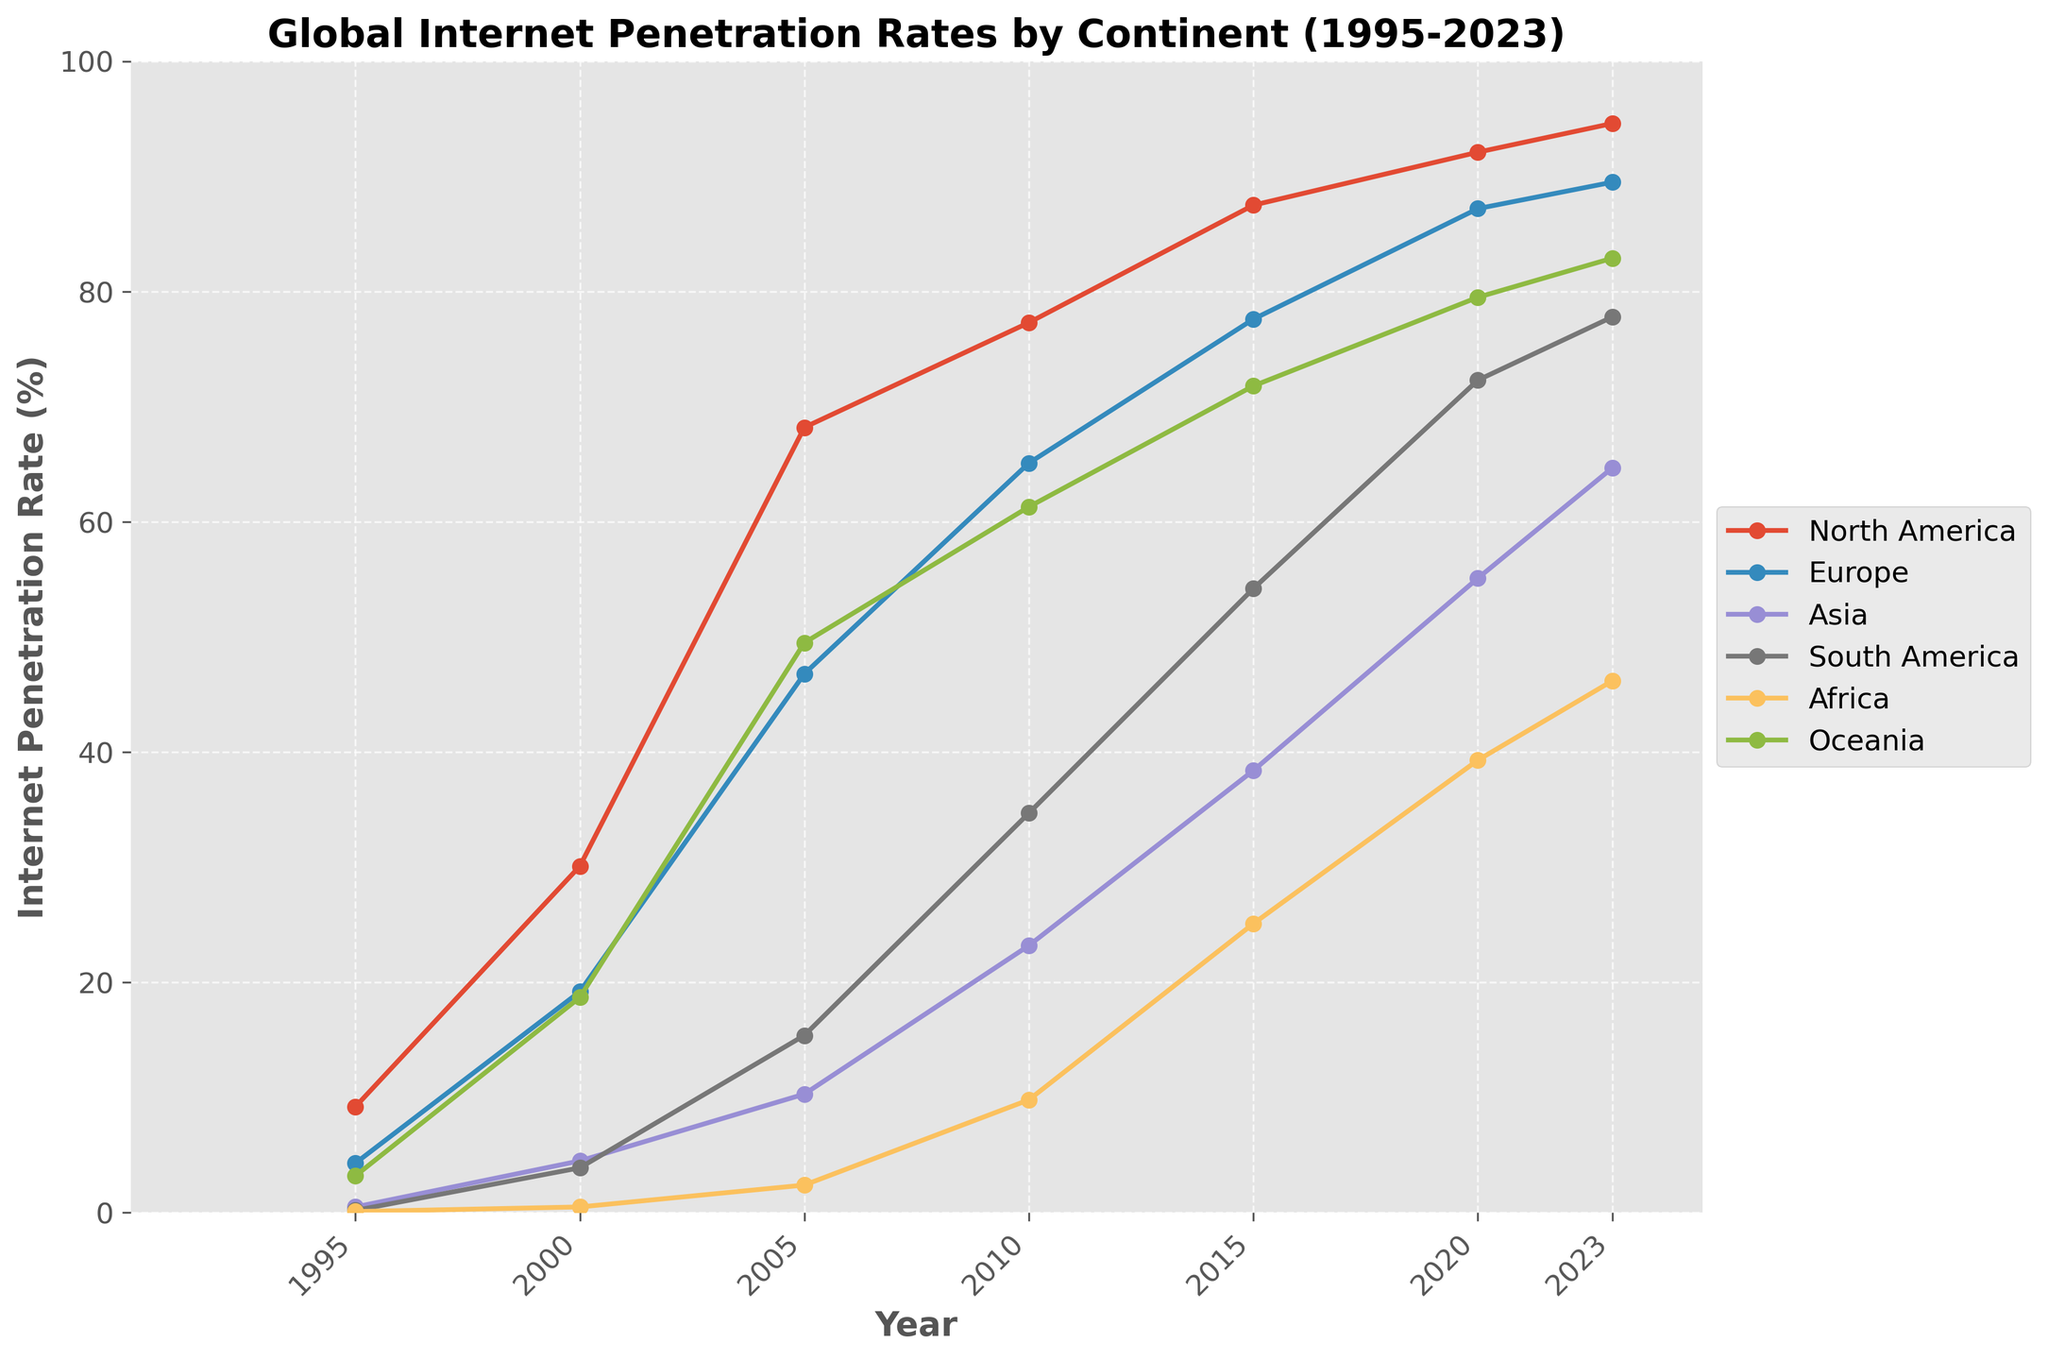What's the trend in internet penetration rates in Africa from 1995 to 2023? Looking at the line for Africa, we see that it starts very low in 1995 and shows a steady rise up until 2023. This indicates a consistent upward trend in internet penetration rates in Africa.
Answer: Steady upward trend Which continent had the highest internet penetration rate in 2005? Referring to the 2005 data points, the highest line on the chart corresponds to North America with an internet penetration rate of 68.2%.
Answer: North America How does the internet penetration rate in Oceania in 2023 compare to North America in 2000? In 2023, the penetration rate in Oceania is marked around 82.9%. In North America in 2000, it was 30.1%. Comparing these visually, Oceania in 2023 is much higher than North America in 2000.
Answer: Oceania in 2023 is higher What is the average internet penetration rate across all continents in 2010? To find the average for 2010, add all the rates for continents: 77.3 (North America) + 65.1 (Europe) + 23.2 (Asia) + 34.7 (South America) + 9.8 (Africa) + 61.3 (Oceania) = 271.4. Then, divide by the number of continents (6): 271.4 / 6 ≈ 45.23%.
Answer: ≈ 45.23% Between which years did Asia see the most significant increase in internet penetration rates? Examination of the line for Asia shows the most significant change between 2015 and 2020, moving from 38.4% to 55.1%. This is the largest leap compared to other periods.
Answer: 2015 to 2020 Which continent saw the least growth in internet penetration rate from 1995 to 2023? Comparing the vertical rise of each line from 1995 to 2023, Africa starts at 0.1% and ends at 46.2%, which indicates it has the least growth compared to the higher endpoints of other continents.
Answer: Africa What is the difference in internet penetration rates between Europe and South America in 2015? In 2015, Europe's rate is 77.6% and South America's is 54.2%. The difference is 77.6% - 54.2% = 23.4%.
Answer: 23.4% Which continent had the lowest internet penetration rate in 2000, and what was the rate? The lowest point on the 2000 axis corresponds to Africa with an internet penetration rate of 0.5%.
Answer: Africa, 0.5% How did South America's internet penetration rate change between 2010 and 2023? In 2010, it started at 34.7% and increased to 77.8% in 2023. This shows South America's rate more than doubled over the period.
Answer: More than doubled In 2020, which continents had internet penetration rates greater than 50%? Referring to the 2020 data points, North America, Europe, Asia, South America, and Oceania all have rates above 50%, while Africa does not.
Answer: North America, Europe, Asia, South America, Oceania 